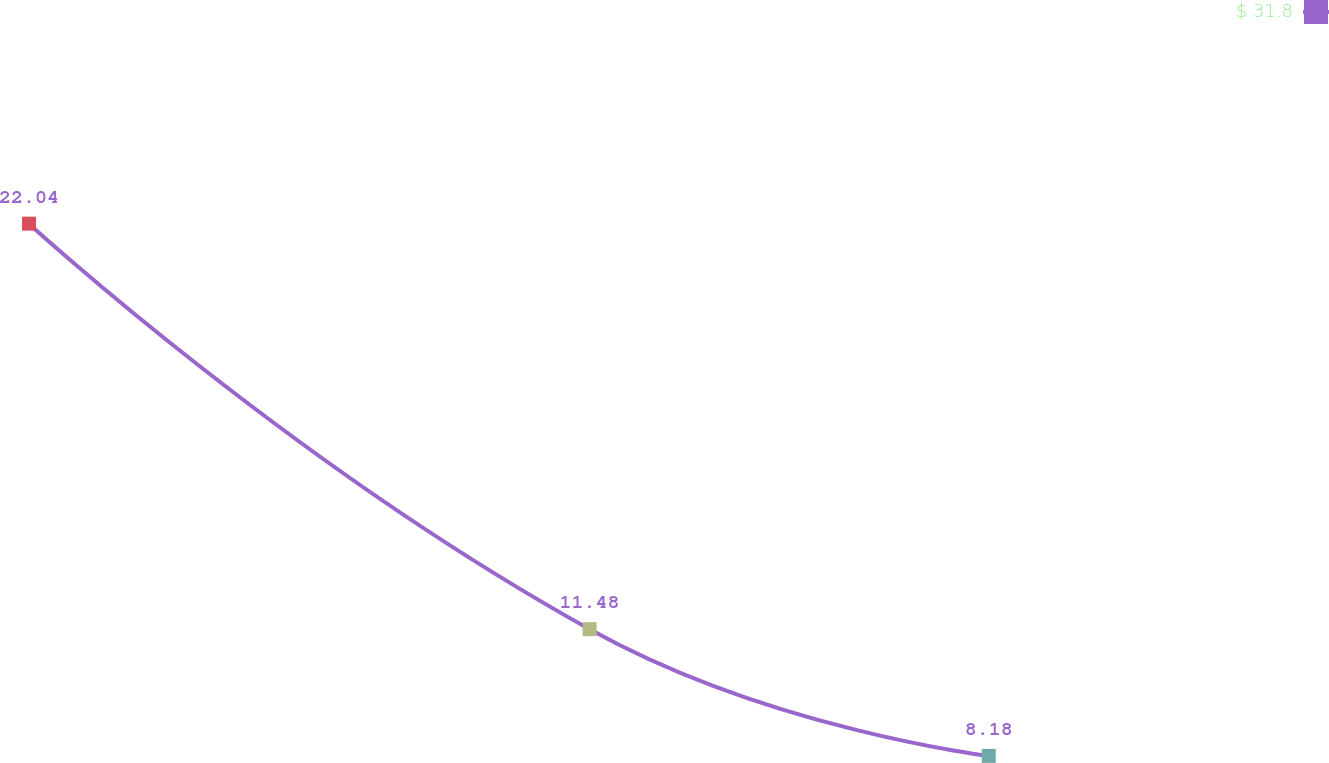Convert chart. <chart><loc_0><loc_0><loc_500><loc_500><line_chart><ecel><fcel>$ 31.8<nl><fcel>1673.96<fcel>22.04<nl><fcel>1957.59<fcel>11.48<nl><fcel>2159.54<fcel>8.18<nl><fcel>2321.57<fcel>6.64<nl></chart> 